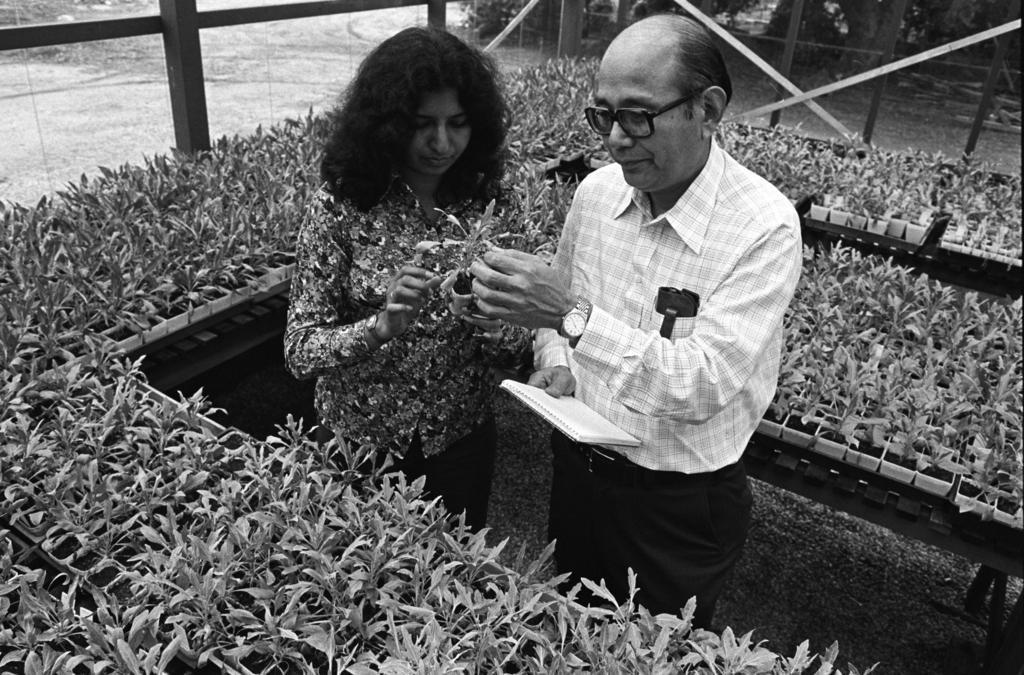Please provide a concise description of this image. In this image I can see number of plants and here I can see two persons are standing. I can see both of them are holding a plant and he is holding a book. I can also see he is wearing shirt, watch and specs. I can see this image is black and white in colour. 